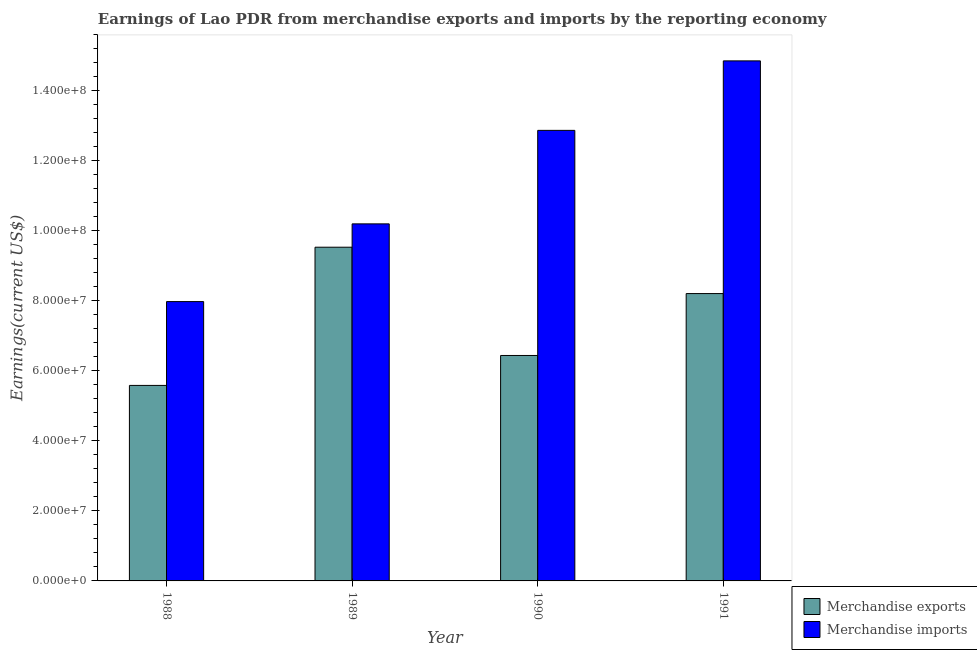How many groups of bars are there?
Give a very brief answer. 4. Are the number of bars per tick equal to the number of legend labels?
Offer a terse response. Yes. Are the number of bars on each tick of the X-axis equal?
Give a very brief answer. Yes. How many bars are there on the 4th tick from the right?
Provide a succinct answer. 2. What is the label of the 3rd group of bars from the left?
Provide a short and direct response. 1990. What is the earnings from merchandise exports in 1991?
Your answer should be compact. 8.21e+07. Across all years, what is the maximum earnings from merchandise exports?
Provide a short and direct response. 9.54e+07. Across all years, what is the minimum earnings from merchandise imports?
Your response must be concise. 7.98e+07. In which year was the earnings from merchandise exports maximum?
Keep it short and to the point. 1989. What is the total earnings from merchandise exports in the graph?
Make the answer very short. 2.98e+08. What is the difference between the earnings from merchandise exports in 1990 and that in 1991?
Give a very brief answer. -1.77e+07. What is the difference between the earnings from merchandise imports in 1988 and the earnings from merchandise exports in 1991?
Your response must be concise. -6.88e+07. What is the average earnings from merchandise exports per year?
Offer a terse response. 7.44e+07. In how many years, is the earnings from merchandise imports greater than 100000000 US$?
Your answer should be compact. 3. What is the ratio of the earnings from merchandise exports in 1990 to that in 1991?
Offer a very short reply. 0.78. Is the difference between the earnings from merchandise imports in 1989 and 1991 greater than the difference between the earnings from merchandise exports in 1989 and 1991?
Offer a terse response. No. What is the difference between the highest and the second highest earnings from merchandise imports?
Provide a succinct answer. 1.99e+07. What is the difference between the highest and the lowest earnings from merchandise exports?
Provide a short and direct response. 3.95e+07. Is the sum of the earnings from merchandise exports in 1989 and 1991 greater than the maximum earnings from merchandise imports across all years?
Provide a short and direct response. Yes. What does the 1st bar from the left in 1989 represents?
Ensure brevity in your answer.  Merchandise exports. What does the 1st bar from the right in 1990 represents?
Offer a terse response. Merchandise imports. How many years are there in the graph?
Make the answer very short. 4. Does the graph contain grids?
Keep it short and to the point. No. How are the legend labels stacked?
Offer a very short reply. Vertical. What is the title of the graph?
Your response must be concise. Earnings of Lao PDR from merchandise exports and imports by the reporting economy. What is the label or title of the X-axis?
Offer a very short reply. Year. What is the label or title of the Y-axis?
Your answer should be compact. Earnings(current US$). What is the Earnings(current US$) in Merchandise exports in 1988?
Provide a short and direct response. 5.59e+07. What is the Earnings(current US$) in Merchandise imports in 1988?
Your answer should be compact. 7.98e+07. What is the Earnings(current US$) of Merchandise exports in 1989?
Your answer should be compact. 9.54e+07. What is the Earnings(current US$) in Merchandise imports in 1989?
Give a very brief answer. 1.02e+08. What is the Earnings(current US$) in Merchandise exports in 1990?
Provide a succinct answer. 6.44e+07. What is the Earnings(current US$) of Merchandise imports in 1990?
Offer a terse response. 1.29e+08. What is the Earnings(current US$) in Merchandise exports in 1991?
Make the answer very short. 8.21e+07. What is the Earnings(current US$) of Merchandise imports in 1991?
Make the answer very short. 1.49e+08. Across all years, what is the maximum Earnings(current US$) of Merchandise exports?
Ensure brevity in your answer.  9.54e+07. Across all years, what is the maximum Earnings(current US$) of Merchandise imports?
Give a very brief answer. 1.49e+08. Across all years, what is the minimum Earnings(current US$) in Merchandise exports?
Provide a succinct answer. 5.59e+07. Across all years, what is the minimum Earnings(current US$) of Merchandise imports?
Give a very brief answer. 7.98e+07. What is the total Earnings(current US$) of Merchandise exports in the graph?
Your answer should be compact. 2.98e+08. What is the total Earnings(current US$) of Merchandise imports in the graph?
Your answer should be very brief. 4.59e+08. What is the difference between the Earnings(current US$) in Merchandise exports in 1988 and that in 1989?
Your answer should be very brief. -3.95e+07. What is the difference between the Earnings(current US$) in Merchandise imports in 1988 and that in 1989?
Your response must be concise. -2.22e+07. What is the difference between the Earnings(current US$) in Merchandise exports in 1988 and that in 1990?
Your answer should be very brief. -8.55e+06. What is the difference between the Earnings(current US$) in Merchandise imports in 1988 and that in 1990?
Provide a succinct answer. -4.89e+07. What is the difference between the Earnings(current US$) in Merchandise exports in 1988 and that in 1991?
Provide a short and direct response. -2.62e+07. What is the difference between the Earnings(current US$) of Merchandise imports in 1988 and that in 1991?
Ensure brevity in your answer.  -6.88e+07. What is the difference between the Earnings(current US$) of Merchandise exports in 1989 and that in 1990?
Provide a succinct answer. 3.09e+07. What is the difference between the Earnings(current US$) in Merchandise imports in 1989 and that in 1990?
Ensure brevity in your answer.  -2.67e+07. What is the difference between the Earnings(current US$) of Merchandise exports in 1989 and that in 1991?
Provide a succinct answer. 1.32e+07. What is the difference between the Earnings(current US$) of Merchandise imports in 1989 and that in 1991?
Give a very brief answer. -4.66e+07. What is the difference between the Earnings(current US$) of Merchandise exports in 1990 and that in 1991?
Offer a terse response. -1.77e+07. What is the difference between the Earnings(current US$) of Merchandise imports in 1990 and that in 1991?
Your answer should be very brief. -1.99e+07. What is the difference between the Earnings(current US$) of Merchandise exports in 1988 and the Earnings(current US$) of Merchandise imports in 1989?
Your answer should be very brief. -4.62e+07. What is the difference between the Earnings(current US$) in Merchandise exports in 1988 and the Earnings(current US$) in Merchandise imports in 1990?
Your answer should be compact. -7.29e+07. What is the difference between the Earnings(current US$) of Merchandise exports in 1988 and the Earnings(current US$) of Merchandise imports in 1991?
Your response must be concise. -9.27e+07. What is the difference between the Earnings(current US$) in Merchandise exports in 1989 and the Earnings(current US$) in Merchandise imports in 1990?
Provide a succinct answer. -3.34e+07. What is the difference between the Earnings(current US$) of Merchandise exports in 1989 and the Earnings(current US$) of Merchandise imports in 1991?
Ensure brevity in your answer.  -5.32e+07. What is the difference between the Earnings(current US$) of Merchandise exports in 1990 and the Earnings(current US$) of Merchandise imports in 1991?
Offer a terse response. -8.42e+07. What is the average Earnings(current US$) in Merchandise exports per year?
Ensure brevity in your answer.  7.44e+07. What is the average Earnings(current US$) in Merchandise imports per year?
Offer a terse response. 1.15e+08. In the year 1988, what is the difference between the Earnings(current US$) of Merchandise exports and Earnings(current US$) of Merchandise imports?
Provide a succinct answer. -2.40e+07. In the year 1989, what is the difference between the Earnings(current US$) in Merchandise exports and Earnings(current US$) in Merchandise imports?
Your response must be concise. -6.67e+06. In the year 1990, what is the difference between the Earnings(current US$) in Merchandise exports and Earnings(current US$) in Merchandise imports?
Give a very brief answer. -6.43e+07. In the year 1991, what is the difference between the Earnings(current US$) in Merchandise exports and Earnings(current US$) in Merchandise imports?
Ensure brevity in your answer.  -6.65e+07. What is the ratio of the Earnings(current US$) of Merchandise exports in 1988 to that in 1989?
Offer a terse response. 0.59. What is the ratio of the Earnings(current US$) of Merchandise imports in 1988 to that in 1989?
Your answer should be compact. 0.78. What is the ratio of the Earnings(current US$) of Merchandise exports in 1988 to that in 1990?
Your response must be concise. 0.87. What is the ratio of the Earnings(current US$) of Merchandise imports in 1988 to that in 1990?
Offer a very short reply. 0.62. What is the ratio of the Earnings(current US$) in Merchandise exports in 1988 to that in 1991?
Give a very brief answer. 0.68. What is the ratio of the Earnings(current US$) in Merchandise imports in 1988 to that in 1991?
Ensure brevity in your answer.  0.54. What is the ratio of the Earnings(current US$) of Merchandise exports in 1989 to that in 1990?
Offer a very short reply. 1.48. What is the ratio of the Earnings(current US$) in Merchandise imports in 1989 to that in 1990?
Ensure brevity in your answer.  0.79. What is the ratio of the Earnings(current US$) in Merchandise exports in 1989 to that in 1991?
Give a very brief answer. 1.16. What is the ratio of the Earnings(current US$) of Merchandise imports in 1989 to that in 1991?
Keep it short and to the point. 0.69. What is the ratio of the Earnings(current US$) in Merchandise exports in 1990 to that in 1991?
Your response must be concise. 0.78. What is the ratio of the Earnings(current US$) of Merchandise imports in 1990 to that in 1991?
Offer a very short reply. 0.87. What is the difference between the highest and the second highest Earnings(current US$) in Merchandise exports?
Offer a terse response. 1.32e+07. What is the difference between the highest and the second highest Earnings(current US$) in Merchandise imports?
Offer a terse response. 1.99e+07. What is the difference between the highest and the lowest Earnings(current US$) of Merchandise exports?
Give a very brief answer. 3.95e+07. What is the difference between the highest and the lowest Earnings(current US$) in Merchandise imports?
Your response must be concise. 6.88e+07. 